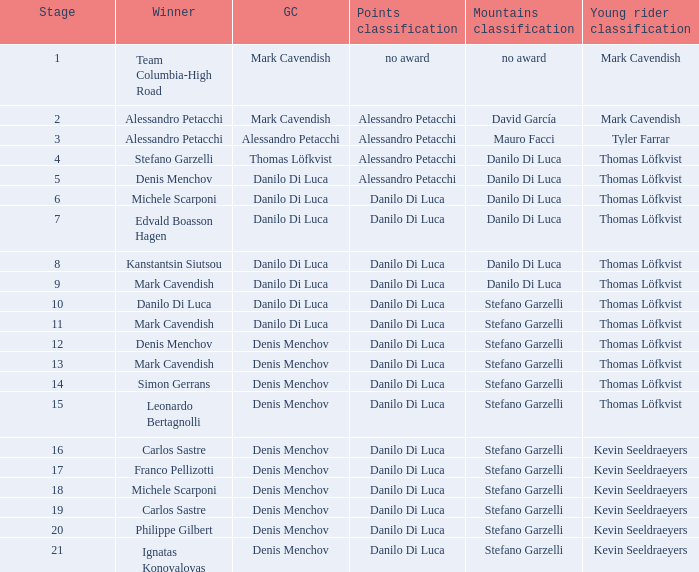When danilo di luca is the winner who is the general classification?  Danilo Di Luca. 